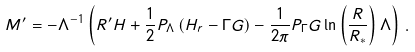<formula> <loc_0><loc_0><loc_500><loc_500>M ^ { \prime } = - \Lambda ^ { - 1 } \left ( R ^ { \prime } H + \frac { 1 } { 2 } P _ { \Lambda } \left ( H _ { r } - \Gamma G \right ) - \frac { 1 } { 2 \pi } P _ { \Gamma } G \ln \left ( \frac { R } { R _ { * } } \right ) \Lambda \right ) \, .</formula> 